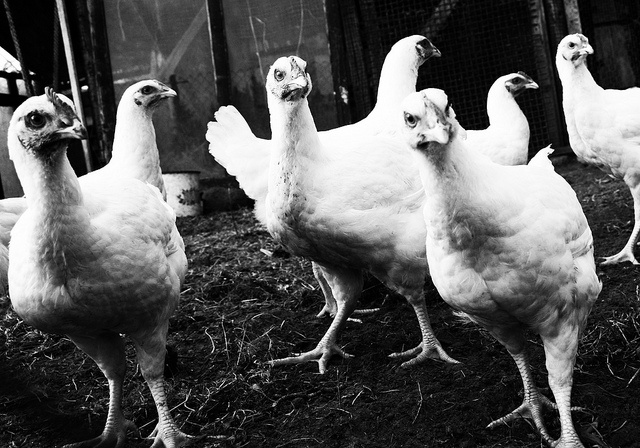Describe the objects in this image and their specific colors. I can see bird in black, lightgray, darkgray, and gray tones, bird in black, lightgray, gray, and darkgray tones, bird in black, lightgray, darkgray, and gray tones, bird in black, white, darkgray, and gray tones, and bird in black, white, darkgray, and gray tones in this image. 